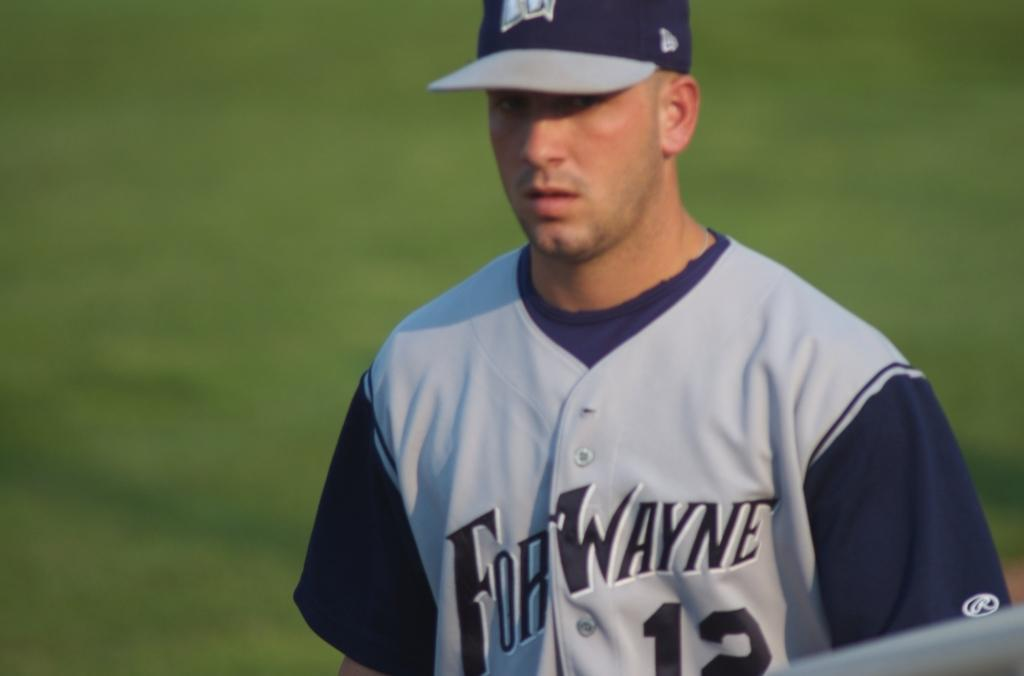Provide a one-sentence caption for the provided image. A baseball player for the Fort Wayne team wears the number 12 jersey. 